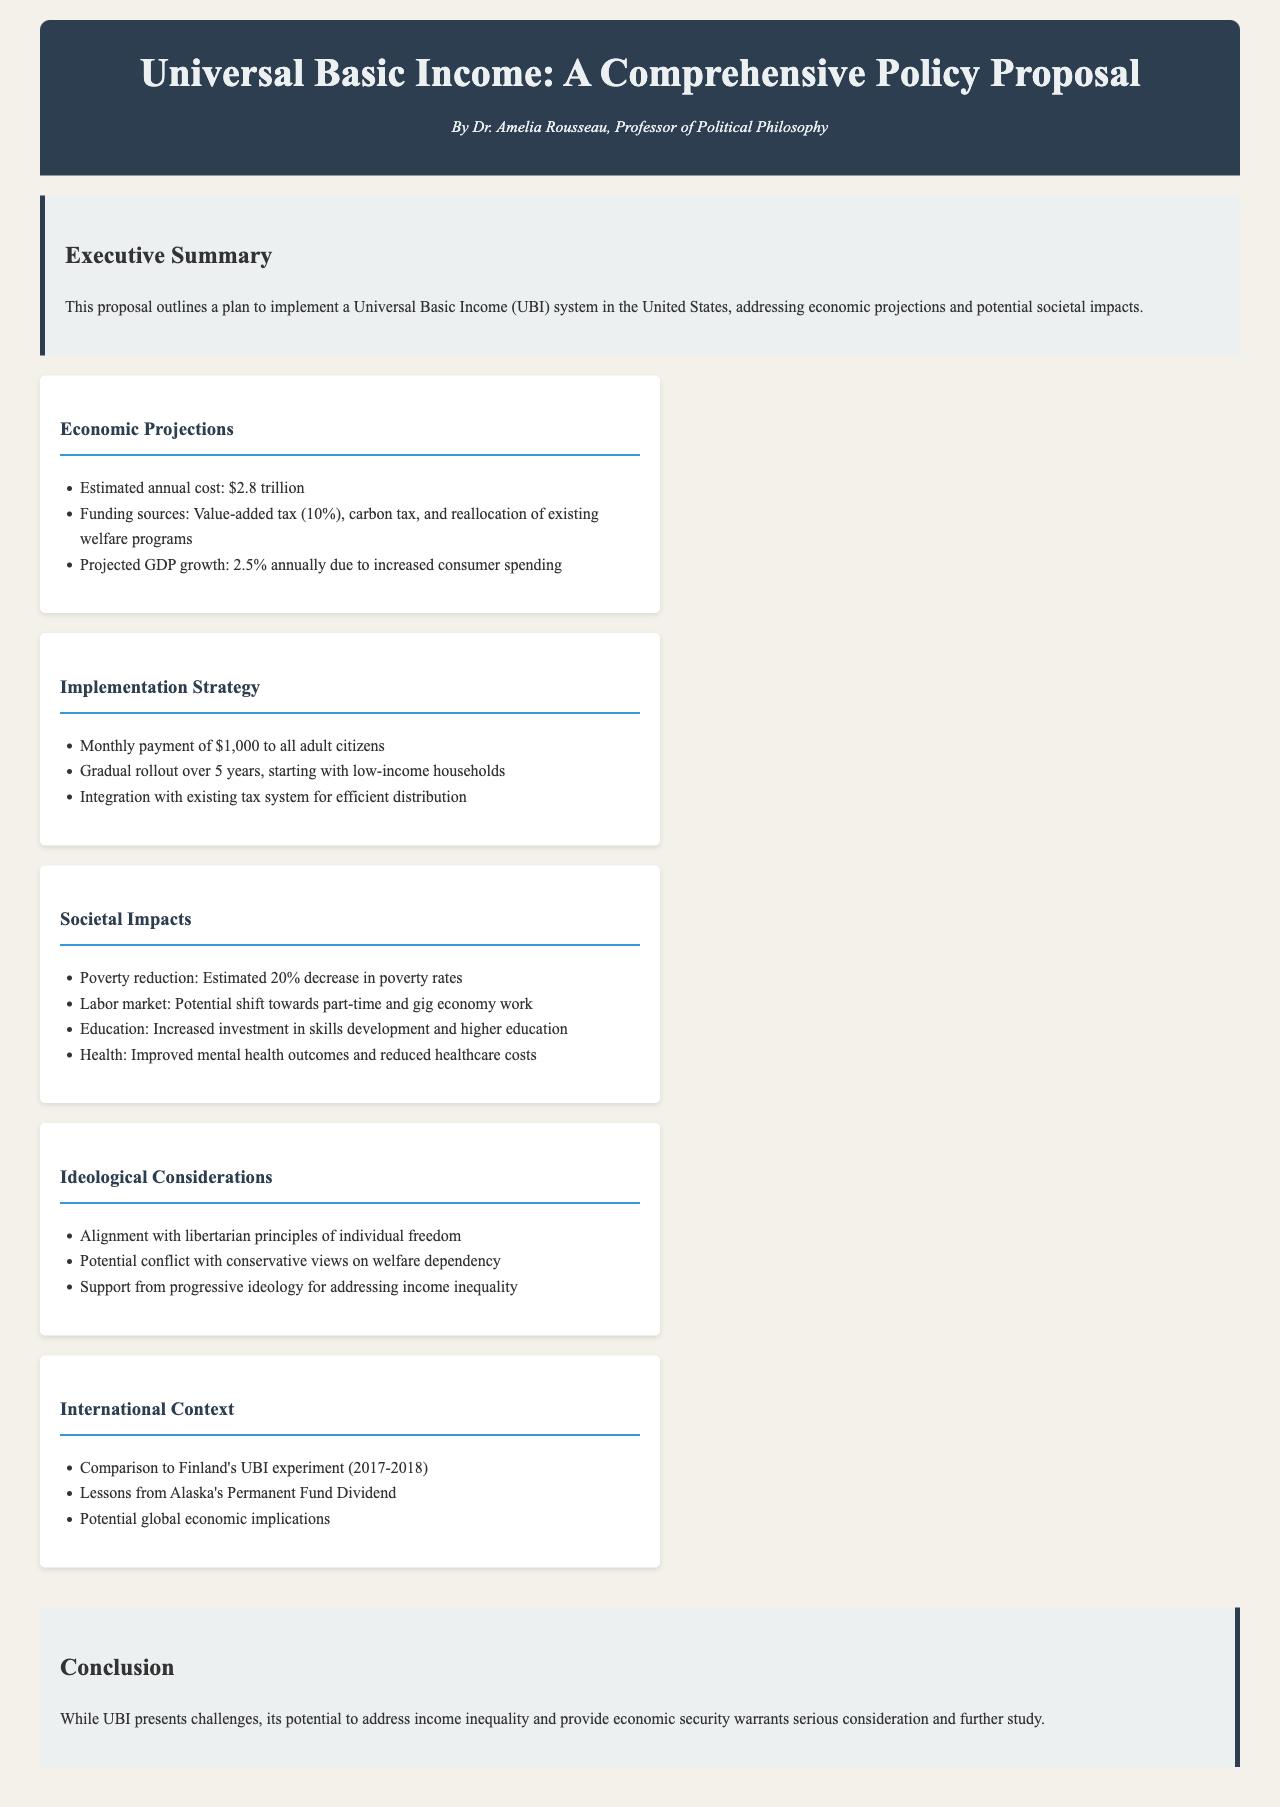What is the estimated annual cost of UBI? The estimated annual cost is mentioned in the economic projections section of the document.
Answer: $2.8 trillion What is the monthly payment each adult citizen would receive? The monthly payment amount is specified in the implementation strategy section of the document.
Answer: $1,000 What is the projected GDP growth due to UBI? The projected GDP growth is noted in the economic projections part of the document.
Answer: 2.5% What is the estimated decrease in poverty rates? The estimated decrease in poverty rates is found in the societal impacts section of the document.
Answer: 20% What are the funding sources for UBI? The funding sources are outlined in the economic projections of the document.
Answer: Value-added tax, carbon tax, and reallocation of existing welfare programs Which ideological principle aligns with UBI? The alignment with ideological principles can be found in the ideological considerations section of the document.
Answer: Individual freedom What was a similar UBI experiment mentioned in the document? The similar UBI experiment is referenced in the international context section.
Answer: Finland's UBI experiment How long is the rollout period for UBI? The rollout period for UBI is detailed in the implementation strategy section of the document.
Answer: 5 years 